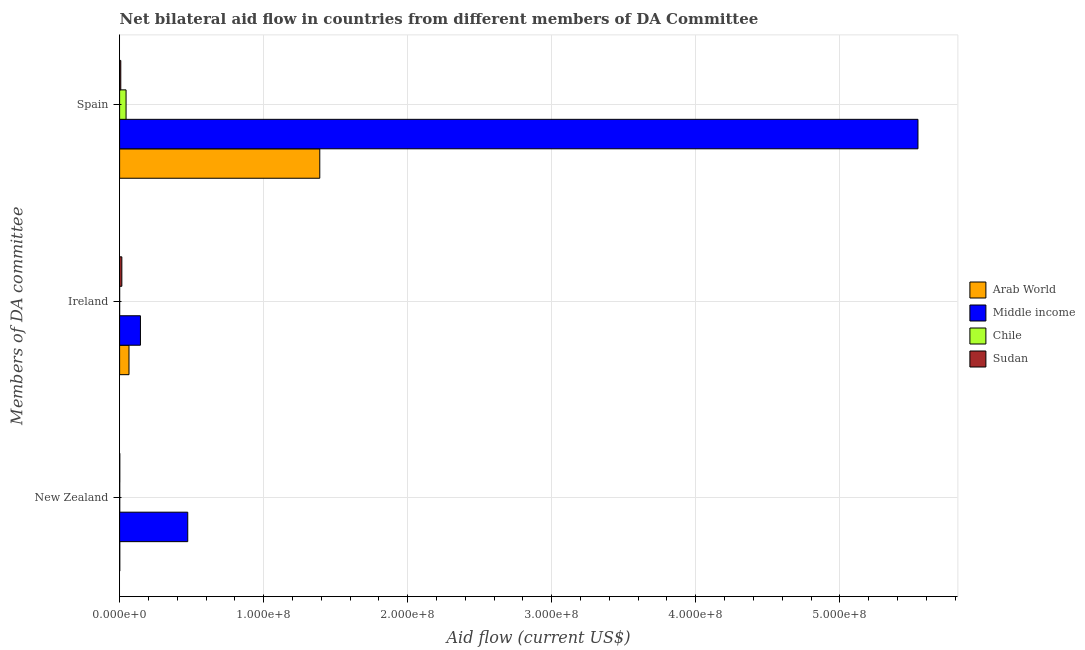How many different coloured bars are there?
Make the answer very short. 4. What is the label of the 1st group of bars from the top?
Your answer should be very brief. Spain. What is the amount of aid provided by ireland in Middle income?
Your response must be concise. 1.45e+07. Across all countries, what is the maximum amount of aid provided by ireland?
Offer a very short reply. 1.45e+07. Across all countries, what is the minimum amount of aid provided by new zealand?
Offer a very short reply. 8.00e+04. In which country was the amount of aid provided by spain minimum?
Provide a short and direct response. Sudan. What is the total amount of aid provided by spain in the graph?
Your answer should be compact. 6.99e+08. What is the difference between the amount of aid provided by new zealand in Sudan and that in Arab World?
Provide a succinct answer. 0. What is the difference between the amount of aid provided by spain in Chile and the amount of aid provided by ireland in Sudan?
Make the answer very short. 2.93e+06. What is the average amount of aid provided by new zealand per country?
Keep it short and to the point. 1.19e+07. What is the difference between the amount of aid provided by spain and amount of aid provided by new zealand in Arab World?
Your answer should be compact. 1.39e+08. What is the ratio of the amount of aid provided by spain in Middle income to that in Sudan?
Offer a very short reply. 675.93. Is the amount of aid provided by new zealand in Chile less than that in Arab World?
Provide a succinct answer. Yes. What is the difference between the highest and the second highest amount of aid provided by spain?
Your response must be concise. 4.15e+08. What is the difference between the highest and the lowest amount of aid provided by new zealand?
Your answer should be very brief. 4.72e+07. What does the 2nd bar from the top in Ireland represents?
Make the answer very short. Chile. What does the 4th bar from the bottom in Ireland represents?
Ensure brevity in your answer.  Sudan. Is it the case that in every country, the sum of the amount of aid provided by new zealand and amount of aid provided by ireland is greater than the amount of aid provided by spain?
Provide a succinct answer. No. How many bars are there?
Give a very brief answer. 12. What is the difference between two consecutive major ticks on the X-axis?
Your answer should be very brief. 1.00e+08. Does the graph contain grids?
Give a very brief answer. Yes. What is the title of the graph?
Keep it short and to the point. Net bilateral aid flow in countries from different members of DA Committee. What is the label or title of the Y-axis?
Make the answer very short. Members of DA committee. What is the Aid flow (current US$) in Middle income in New Zealand?
Make the answer very short. 4.73e+07. What is the Aid flow (current US$) of Chile in New Zealand?
Keep it short and to the point. 8.00e+04. What is the Aid flow (current US$) in Sudan in New Zealand?
Your answer should be compact. 1.20e+05. What is the Aid flow (current US$) in Arab World in Ireland?
Make the answer very short. 6.52e+06. What is the Aid flow (current US$) in Middle income in Ireland?
Provide a succinct answer. 1.45e+07. What is the Aid flow (current US$) in Chile in Ireland?
Give a very brief answer. 2.00e+04. What is the Aid flow (current US$) of Sudan in Ireland?
Your response must be concise. 1.56e+06. What is the Aid flow (current US$) of Arab World in Spain?
Your response must be concise. 1.39e+08. What is the Aid flow (current US$) in Middle income in Spain?
Offer a terse response. 5.54e+08. What is the Aid flow (current US$) of Chile in Spain?
Provide a succinct answer. 4.49e+06. What is the Aid flow (current US$) in Sudan in Spain?
Your answer should be very brief. 8.20e+05. Across all Members of DA committee, what is the maximum Aid flow (current US$) in Arab World?
Offer a terse response. 1.39e+08. Across all Members of DA committee, what is the maximum Aid flow (current US$) in Middle income?
Your response must be concise. 5.54e+08. Across all Members of DA committee, what is the maximum Aid flow (current US$) in Chile?
Your answer should be very brief. 4.49e+06. Across all Members of DA committee, what is the maximum Aid flow (current US$) of Sudan?
Your response must be concise. 1.56e+06. Across all Members of DA committee, what is the minimum Aid flow (current US$) of Middle income?
Your answer should be compact. 1.45e+07. Across all Members of DA committee, what is the minimum Aid flow (current US$) in Chile?
Give a very brief answer. 2.00e+04. What is the total Aid flow (current US$) of Arab World in the graph?
Your answer should be compact. 1.46e+08. What is the total Aid flow (current US$) in Middle income in the graph?
Offer a terse response. 6.16e+08. What is the total Aid flow (current US$) in Chile in the graph?
Give a very brief answer. 4.59e+06. What is the total Aid flow (current US$) in Sudan in the graph?
Provide a short and direct response. 2.50e+06. What is the difference between the Aid flow (current US$) in Arab World in New Zealand and that in Ireland?
Your answer should be compact. -6.40e+06. What is the difference between the Aid flow (current US$) of Middle income in New Zealand and that in Ireland?
Your answer should be very brief. 3.28e+07. What is the difference between the Aid flow (current US$) of Sudan in New Zealand and that in Ireland?
Keep it short and to the point. -1.44e+06. What is the difference between the Aid flow (current US$) in Arab World in New Zealand and that in Spain?
Your answer should be compact. -1.39e+08. What is the difference between the Aid flow (current US$) of Middle income in New Zealand and that in Spain?
Offer a very short reply. -5.07e+08. What is the difference between the Aid flow (current US$) in Chile in New Zealand and that in Spain?
Your answer should be compact. -4.41e+06. What is the difference between the Aid flow (current US$) of Sudan in New Zealand and that in Spain?
Make the answer very short. -7.00e+05. What is the difference between the Aid flow (current US$) in Arab World in Ireland and that in Spain?
Your answer should be very brief. -1.32e+08. What is the difference between the Aid flow (current US$) in Middle income in Ireland and that in Spain?
Give a very brief answer. -5.40e+08. What is the difference between the Aid flow (current US$) of Chile in Ireland and that in Spain?
Your answer should be compact. -4.47e+06. What is the difference between the Aid flow (current US$) in Sudan in Ireland and that in Spain?
Provide a short and direct response. 7.40e+05. What is the difference between the Aid flow (current US$) in Arab World in New Zealand and the Aid flow (current US$) in Middle income in Ireland?
Give a very brief answer. -1.43e+07. What is the difference between the Aid flow (current US$) of Arab World in New Zealand and the Aid flow (current US$) of Chile in Ireland?
Ensure brevity in your answer.  1.00e+05. What is the difference between the Aid flow (current US$) in Arab World in New Zealand and the Aid flow (current US$) in Sudan in Ireland?
Make the answer very short. -1.44e+06. What is the difference between the Aid flow (current US$) in Middle income in New Zealand and the Aid flow (current US$) in Chile in Ireland?
Offer a terse response. 4.73e+07. What is the difference between the Aid flow (current US$) of Middle income in New Zealand and the Aid flow (current US$) of Sudan in Ireland?
Your answer should be very brief. 4.58e+07. What is the difference between the Aid flow (current US$) of Chile in New Zealand and the Aid flow (current US$) of Sudan in Ireland?
Provide a succinct answer. -1.48e+06. What is the difference between the Aid flow (current US$) of Arab World in New Zealand and the Aid flow (current US$) of Middle income in Spain?
Offer a very short reply. -5.54e+08. What is the difference between the Aid flow (current US$) of Arab World in New Zealand and the Aid flow (current US$) of Chile in Spain?
Offer a terse response. -4.37e+06. What is the difference between the Aid flow (current US$) in Arab World in New Zealand and the Aid flow (current US$) in Sudan in Spain?
Your answer should be very brief. -7.00e+05. What is the difference between the Aid flow (current US$) of Middle income in New Zealand and the Aid flow (current US$) of Chile in Spain?
Your response must be concise. 4.28e+07. What is the difference between the Aid flow (current US$) of Middle income in New Zealand and the Aid flow (current US$) of Sudan in Spain?
Ensure brevity in your answer.  4.65e+07. What is the difference between the Aid flow (current US$) in Chile in New Zealand and the Aid flow (current US$) in Sudan in Spain?
Give a very brief answer. -7.40e+05. What is the difference between the Aid flow (current US$) in Arab World in Ireland and the Aid flow (current US$) in Middle income in Spain?
Provide a short and direct response. -5.48e+08. What is the difference between the Aid flow (current US$) of Arab World in Ireland and the Aid flow (current US$) of Chile in Spain?
Provide a succinct answer. 2.03e+06. What is the difference between the Aid flow (current US$) of Arab World in Ireland and the Aid flow (current US$) of Sudan in Spain?
Keep it short and to the point. 5.70e+06. What is the difference between the Aid flow (current US$) in Middle income in Ireland and the Aid flow (current US$) in Chile in Spain?
Give a very brief answer. 9.97e+06. What is the difference between the Aid flow (current US$) in Middle income in Ireland and the Aid flow (current US$) in Sudan in Spain?
Your answer should be compact. 1.36e+07. What is the difference between the Aid flow (current US$) of Chile in Ireland and the Aid flow (current US$) of Sudan in Spain?
Keep it short and to the point. -8.00e+05. What is the average Aid flow (current US$) in Arab World per Members of DA committee?
Provide a short and direct response. 4.85e+07. What is the average Aid flow (current US$) in Middle income per Members of DA committee?
Offer a very short reply. 2.05e+08. What is the average Aid flow (current US$) in Chile per Members of DA committee?
Keep it short and to the point. 1.53e+06. What is the average Aid flow (current US$) of Sudan per Members of DA committee?
Make the answer very short. 8.33e+05. What is the difference between the Aid flow (current US$) of Arab World and Aid flow (current US$) of Middle income in New Zealand?
Make the answer very short. -4.72e+07. What is the difference between the Aid flow (current US$) in Arab World and Aid flow (current US$) in Chile in New Zealand?
Give a very brief answer. 4.00e+04. What is the difference between the Aid flow (current US$) of Arab World and Aid flow (current US$) of Sudan in New Zealand?
Give a very brief answer. 0. What is the difference between the Aid flow (current US$) of Middle income and Aid flow (current US$) of Chile in New Zealand?
Provide a short and direct response. 4.72e+07. What is the difference between the Aid flow (current US$) of Middle income and Aid flow (current US$) of Sudan in New Zealand?
Provide a short and direct response. 4.72e+07. What is the difference between the Aid flow (current US$) in Chile and Aid flow (current US$) in Sudan in New Zealand?
Give a very brief answer. -4.00e+04. What is the difference between the Aid flow (current US$) in Arab World and Aid flow (current US$) in Middle income in Ireland?
Provide a short and direct response. -7.94e+06. What is the difference between the Aid flow (current US$) in Arab World and Aid flow (current US$) in Chile in Ireland?
Provide a succinct answer. 6.50e+06. What is the difference between the Aid flow (current US$) of Arab World and Aid flow (current US$) of Sudan in Ireland?
Ensure brevity in your answer.  4.96e+06. What is the difference between the Aid flow (current US$) of Middle income and Aid flow (current US$) of Chile in Ireland?
Make the answer very short. 1.44e+07. What is the difference between the Aid flow (current US$) in Middle income and Aid flow (current US$) in Sudan in Ireland?
Give a very brief answer. 1.29e+07. What is the difference between the Aid flow (current US$) in Chile and Aid flow (current US$) in Sudan in Ireland?
Your response must be concise. -1.54e+06. What is the difference between the Aid flow (current US$) of Arab World and Aid flow (current US$) of Middle income in Spain?
Offer a very short reply. -4.15e+08. What is the difference between the Aid flow (current US$) of Arab World and Aid flow (current US$) of Chile in Spain?
Your response must be concise. 1.34e+08. What is the difference between the Aid flow (current US$) in Arab World and Aid flow (current US$) in Sudan in Spain?
Provide a succinct answer. 1.38e+08. What is the difference between the Aid flow (current US$) in Middle income and Aid flow (current US$) in Chile in Spain?
Provide a short and direct response. 5.50e+08. What is the difference between the Aid flow (current US$) of Middle income and Aid flow (current US$) of Sudan in Spain?
Ensure brevity in your answer.  5.53e+08. What is the difference between the Aid flow (current US$) in Chile and Aid flow (current US$) in Sudan in Spain?
Give a very brief answer. 3.67e+06. What is the ratio of the Aid flow (current US$) of Arab World in New Zealand to that in Ireland?
Give a very brief answer. 0.02. What is the ratio of the Aid flow (current US$) of Middle income in New Zealand to that in Ireland?
Provide a succinct answer. 3.27. What is the ratio of the Aid flow (current US$) of Chile in New Zealand to that in Ireland?
Offer a terse response. 4. What is the ratio of the Aid flow (current US$) in Sudan in New Zealand to that in Ireland?
Your answer should be compact. 0.08. What is the ratio of the Aid flow (current US$) in Arab World in New Zealand to that in Spain?
Provide a succinct answer. 0. What is the ratio of the Aid flow (current US$) in Middle income in New Zealand to that in Spain?
Keep it short and to the point. 0.09. What is the ratio of the Aid flow (current US$) in Chile in New Zealand to that in Spain?
Give a very brief answer. 0.02. What is the ratio of the Aid flow (current US$) in Sudan in New Zealand to that in Spain?
Your answer should be very brief. 0.15. What is the ratio of the Aid flow (current US$) in Arab World in Ireland to that in Spain?
Provide a short and direct response. 0.05. What is the ratio of the Aid flow (current US$) in Middle income in Ireland to that in Spain?
Ensure brevity in your answer.  0.03. What is the ratio of the Aid flow (current US$) of Chile in Ireland to that in Spain?
Give a very brief answer. 0. What is the ratio of the Aid flow (current US$) of Sudan in Ireland to that in Spain?
Offer a terse response. 1.9. What is the difference between the highest and the second highest Aid flow (current US$) in Arab World?
Provide a succinct answer. 1.32e+08. What is the difference between the highest and the second highest Aid flow (current US$) in Middle income?
Provide a short and direct response. 5.07e+08. What is the difference between the highest and the second highest Aid flow (current US$) of Chile?
Provide a short and direct response. 4.41e+06. What is the difference between the highest and the second highest Aid flow (current US$) in Sudan?
Provide a succinct answer. 7.40e+05. What is the difference between the highest and the lowest Aid flow (current US$) in Arab World?
Make the answer very short. 1.39e+08. What is the difference between the highest and the lowest Aid flow (current US$) of Middle income?
Ensure brevity in your answer.  5.40e+08. What is the difference between the highest and the lowest Aid flow (current US$) of Chile?
Keep it short and to the point. 4.47e+06. What is the difference between the highest and the lowest Aid flow (current US$) in Sudan?
Your response must be concise. 1.44e+06. 